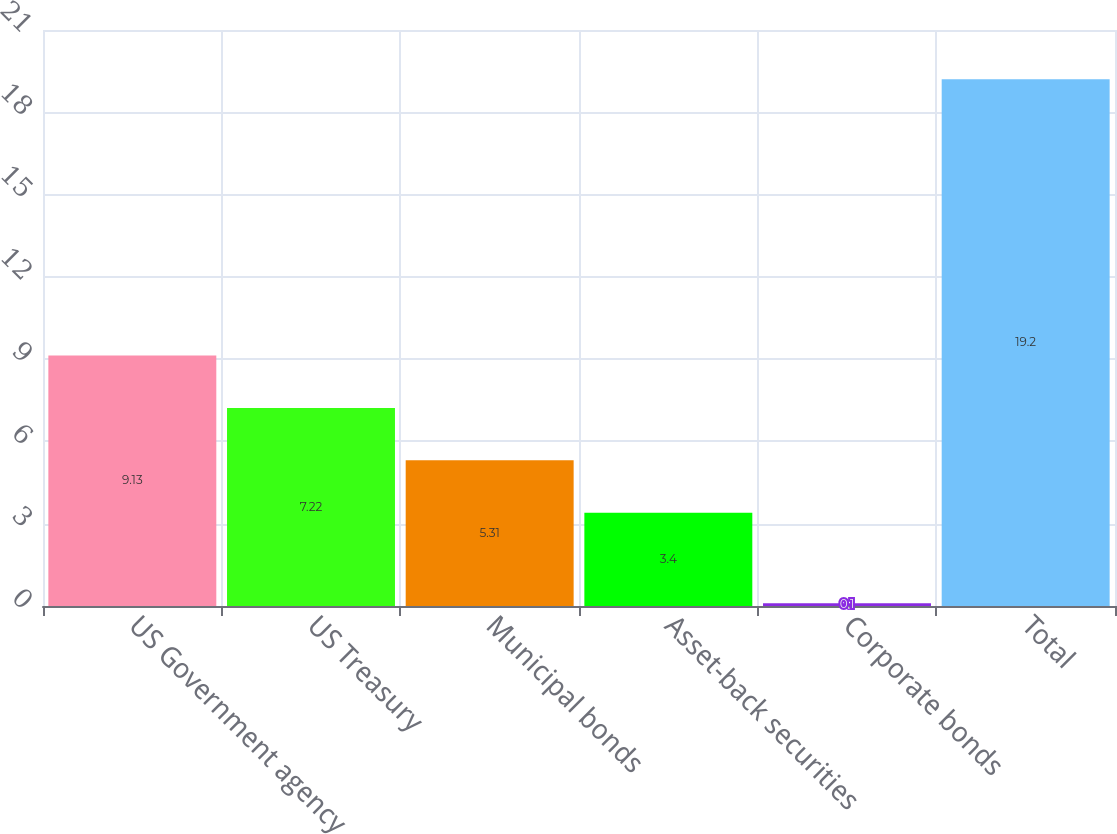Convert chart to OTSL. <chart><loc_0><loc_0><loc_500><loc_500><bar_chart><fcel>US Government agency<fcel>US Treasury<fcel>Municipal bonds<fcel>Asset-back securities<fcel>Corporate bonds<fcel>Total<nl><fcel>9.13<fcel>7.22<fcel>5.31<fcel>3.4<fcel>0.1<fcel>19.2<nl></chart> 